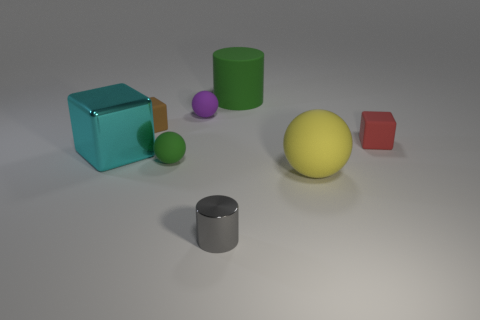Are there any other things that are the same size as the green rubber ball?
Your response must be concise. Yes. Are there any tiny cylinders on the left side of the gray cylinder?
Provide a short and direct response. No. How many other purple objects are the same shape as the purple matte object?
Ensure brevity in your answer.  0. What is the color of the tiny cube to the left of the small thing to the right of the green matte object that is to the right of the gray shiny object?
Keep it short and to the point. Brown. Does the green thing that is in front of the big block have the same material as the large thing on the left side of the small gray metallic cylinder?
Give a very brief answer. No. How many objects are matte objects behind the small purple thing or brown matte balls?
Give a very brief answer. 1. What number of things are blue rubber things or cylinders that are behind the large cyan metal cube?
Your answer should be very brief. 1. What number of yellow blocks have the same size as the red matte thing?
Your response must be concise. 0. Is the number of tiny gray cylinders behind the tiny green thing less than the number of small purple matte things behind the red rubber block?
Provide a succinct answer. Yes. How many matte objects are either cylinders or purple balls?
Provide a succinct answer. 2. 